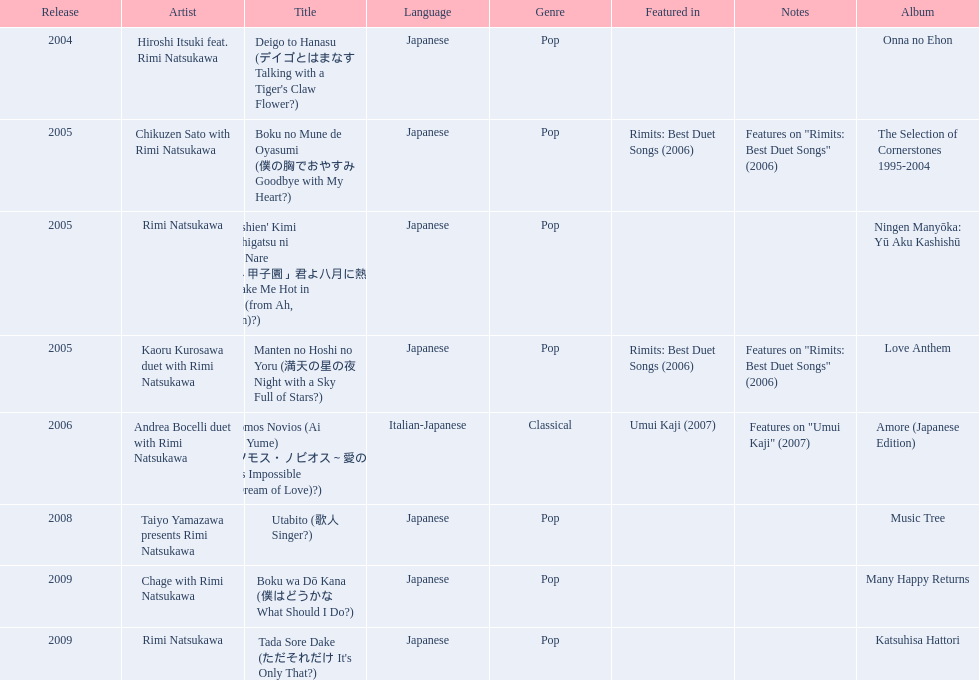What has been the last song this artist has made an other appearance on? Tada Sore Dake. Help me parse the entirety of this table. {'header': ['Release', 'Artist', 'Title', 'Language', 'Genre', 'Featured in', 'Notes', 'Album'], 'rows': [['2004', 'Hiroshi Itsuki feat. Rimi Natsukawa', "Deigo to Hanasu (デイゴとはまなす Talking with a Tiger's Claw Flower?)", 'Japanese', 'Pop', '', '', 'Onna no Ehon'], ['2005', 'Chikuzen Sato with Rimi Natsukawa', 'Boku no Mune de Oyasumi (僕の胸でおやすみ Goodbye with My Heart?)', 'Japanese', 'Pop', 'Rimits: Best Duet Songs (2006)', 'Features on "Rimits: Best Duet Songs" (2006)', 'The Selection of Cornerstones 1995-2004'], ['2005', 'Rimi Natsukawa', "'Aa Kōshien' Kimi yo Hachigatsu ni Atsuku Nare (「あゝ甲子園」君よ八月に熱くなれ You Make Me Hot in August (from Ah, Kōshien)?)", 'Japanese', 'Pop', '', '', 'Ningen Manyōka: Yū Aku Kashishū'], ['2005', 'Kaoru Kurosawa duet with Rimi Natsukawa', 'Manten no Hoshi no Yoru (満天の星の夜 Night with a Sky Full of Stars?)', 'Japanese', 'Pop', 'Rimits: Best Duet Songs (2006)', 'Features on "Rimits: Best Duet Songs" (2006)', 'Love Anthem'], ['2006', 'Andrea Bocelli duet with Rimi Natsukawa', "Somos Novios (Ai no Yume) (ソモス・ノビオス～愛の夢 It's Impossible (Dream of Love)?)", 'Italian-Japanese', 'Classical', 'Umui Kaji (2007)', 'Features on "Umui Kaji" (2007)', 'Amore (Japanese Edition)'], ['2008', 'Taiyo Yamazawa presents Rimi Natsukawa', 'Utabito (歌人 Singer?)', 'Japanese', 'Pop', '', '', 'Music Tree'], ['2009', 'Chage with Rimi Natsukawa', 'Boku wa Dō Kana (僕はどうかな What Should I Do?)', 'Japanese', 'Pop', '', '', 'Many Happy Returns'], ['2009', 'Rimi Natsukawa', "Tada Sore Dake (ただそれだけ It's Only That?)", 'Japanese', 'Pop', '', '', 'Katsuhisa Hattori']]} 